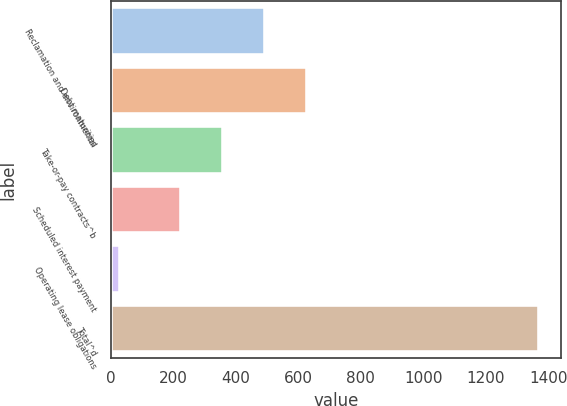Convert chart. <chart><loc_0><loc_0><loc_500><loc_500><bar_chart><fcel>Reclamation and environmental<fcel>Debt maturities<fcel>Take-or-pay contracts^b<fcel>Scheduled interest payment<fcel>Operating lease obligations<fcel>Total^d<nl><fcel>494.2<fcel>628.3<fcel>360.1<fcel>226<fcel>31<fcel>1372<nl></chart> 